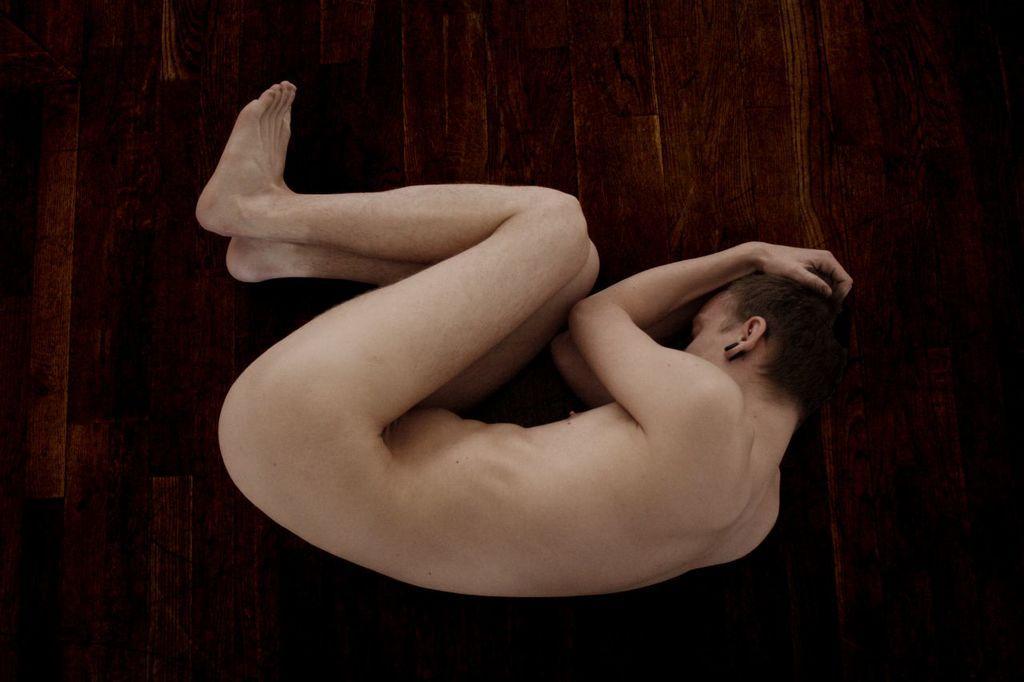In one or two sentences, can you explain what this image depicts? As we can see in the image there is a person sleeping on wooden floor. 